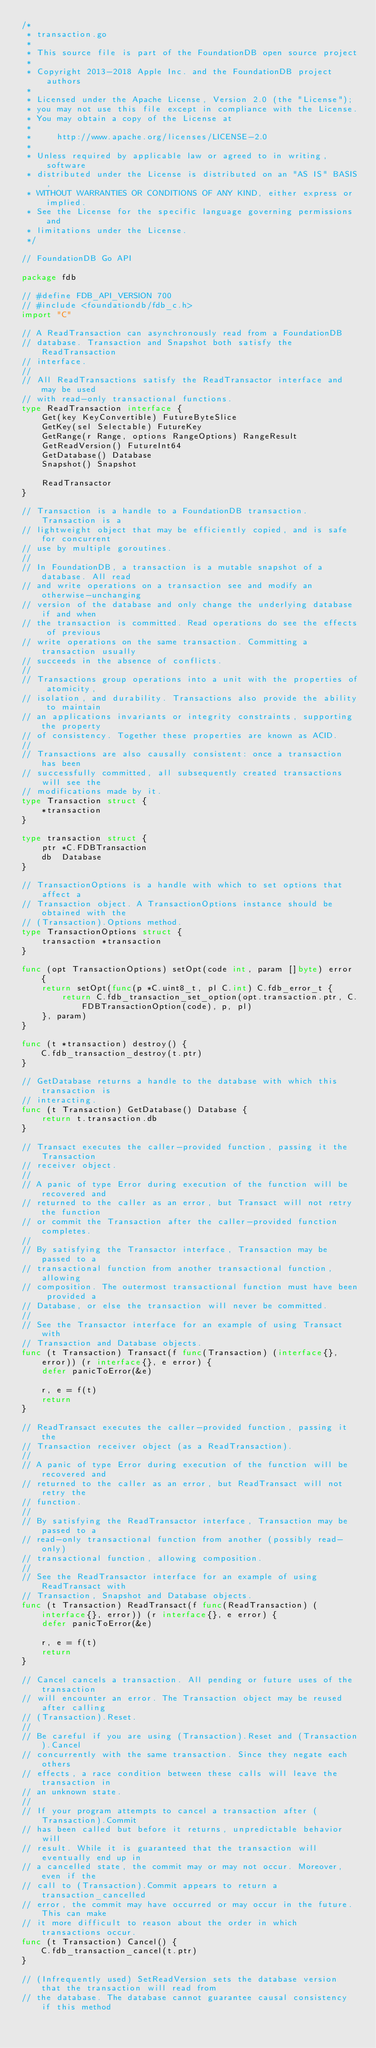<code> <loc_0><loc_0><loc_500><loc_500><_Go_>/*
 * transaction.go
 *
 * This source file is part of the FoundationDB open source project
 *
 * Copyright 2013-2018 Apple Inc. and the FoundationDB project authors
 *
 * Licensed under the Apache License, Version 2.0 (the "License");
 * you may not use this file except in compliance with the License.
 * You may obtain a copy of the License at
 *
 *     http://www.apache.org/licenses/LICENSE-2.0
 *
 * Unless required by applicable law or agreed to in writing, software
 * distributed under the License is distributed on an "AS IS" BASIS,
 * WITHOUT WARRANTIES OR CONDITIONS OF ANY KIND, either express or implied.
 * See the License for the specific language governing permissions and
 * limitations under the License.
 */

// FoundationDB Go API

package fdb

// #define FDB_API_VERSION 700
// #include <foundationdb/fdb_c.h>
import "C"

// A ReadTransaction can asynchronously read from a FoundationDB
// database. Transaction and Snapshot both satisfy the ReadTransaction
// interface.
//
// All ReadTransactions satisfy the ReadTransactor interface and may be used
// with read-only transactional functions.
type ReadTransaction interface {
	Get(key KeyConvertible) FutureByteSlice
	GetKey(sel Selectable) FutureKey
	GetRange(r Range, options RangeOptions) RangeResult
	GetReadVersion() FutureInt64
	GetDatabase() Database
	Snapshot() Snapshot

	ReadTransactor
}

// Transaction is a handle to a FoundationDB transaction. Transaction is a
// lightweight object that may be efficiently copied, and is safe for concurrent
// use by multiple goroutines.
//
// In FoundationDB, a transaction is a mutable snapshot of a database. All read
// and write operations on a transaction see and modify an otherwise-unchanging
// version of the database and only change the underlying database if and when
// the transaction is committed. Read operations do see the effects of previous
// write operations on the same transaction. Committing a transaction usually
// succeeds in the absence of conflicts.
//
// Transactions group operations into a unit with the properties of atomicity,
// isolation, and durability. Transactions also provide the ability to maintain
// an applications invariants or integrity constraints, supporting the property
// of consistency. Together these properties are known as ACID.
//
// Transactions are also causally consistent: once a transaction has been
// successfully committed, all subsequently created transactions will see the
// modifications made by it.
type Transaction struct {
	*transaction
}

type transaction struct {
	ptr *C.FDBTransaction
	db  Database
}

// TransactionOptions is a handle with which to set options that affect a
// Transaction object. A TransactionOptions instance should be obtained with the
// (Transaction).Options method.
type TransactionOptions struct {
	transaction *transaction
}

func (opt TransactionOptions) setOpt(code int, param []byte) error {
	return setOpt(func(p *C.uint8_t, pl C.int) C.fdb_error_t {
		return C.fdb_transaction_set_option(opt.transaction.ptr, C.FDBTransactionOption(code), p, pl)
	}, param)
}

func (t *transaction) destroy() {
	C.fdb_transaction_destroy(t.ptr)
}

// GetDatabase returns a handle to the database with which this transaction is
// interacting.
func (t Transaction) GetDatabase() Database {
	return t.transaction.db
}

// Transact executes the caller-provided function, passing it the Transaction
// receiver object.
//
// A panic of type Error during execution of the function will be recovered and
// returned to the caller as an error, but Transact will not retry the function
// or commit the Transaction after the caller-provided function completes.
//
// By satisfying the Transactor interface, Transaction may be passed to a
// transactional function from another transactional function, allowing
// composition. The outermost transactional function must have been provided a
// Database, or else the transaction will never be committed.
//
// See the Transactor interface for an example of using Transact with
// Transaction and Database objects.
func (t Transaction) Transact(f func(Transaction) (interface{}, error)) (r interface{}, e error) {
	defer panicToError(&e)

	r, e = f(t)
	return
}

// ReadTransact executes the caller-provided function, passing it the
// Transaction receiver object (as a ReadTransaction).
//
// A panic of type Error during execution of the function will be recovered and
// returned to the caller as an error, but ReadTransact will not retry the
// function.
//
// By satisfying the ReadTransactor interface, Transaction may be passed to a
// read-only transactional function from another (possibly read-only)
// transactional function, allowing composition.
//
// See the ReadTransactor interface for an example of using ReadTransact with
// Transaction, Snapshot and Database objects.
func (t Transaction) ReadTransact(f func(ReadTransaction) (interface{}, error)) (r interface{}, e error) {
	defer panicToError(&e)

	r, e = f(t)
	return
}

// Cancel cancels a transaction. All pending or future uses of the transaction
// will encounter an error. The Transaction object may be reused after calling
// (Transaction).Reset.
//
// Be careful if you are using (Transaction).Reset and (Transaction).Cancel
// concurrently with the same transaction. Since they negate each others
// effects, a race condition between these calls will leave the transaction in
// an unknown state.
//
// If your program attempts to cancel a transaction after (Transaction).Commit
// has been called but before it returns, unpredictable behavior will
// result. While it is guaranteed that the transaction will eventually end up in
// a cancelled state, the commit may or may not occur. Moreover, even if the
// call to (Transaction).Commit appears to return a transaction_cancelled
// error, the commit may have occurred or may occur in the future. This can make
// it more difficult to reason about the order in which transactions occur.
func (t Transaction) Cancel() {
	C.fdb_transaction_cancel(t.ptr)
}

// (Infrequently used) SetReadVersion sets the database version that the transaction will read from
// the database. The database cannot guarantee causal consistency if this method</code> 